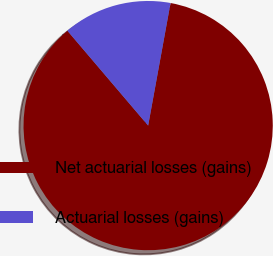Convert chart to OTSL. <chart><loc_0><loc_0><loc_500><loc_500><pie_chart><fcel>Net actuarial losses (gains)<fcel>Actuarial losses (gains)<nl><fcel>85.9%<fcel>14.1%<nl></chart> 